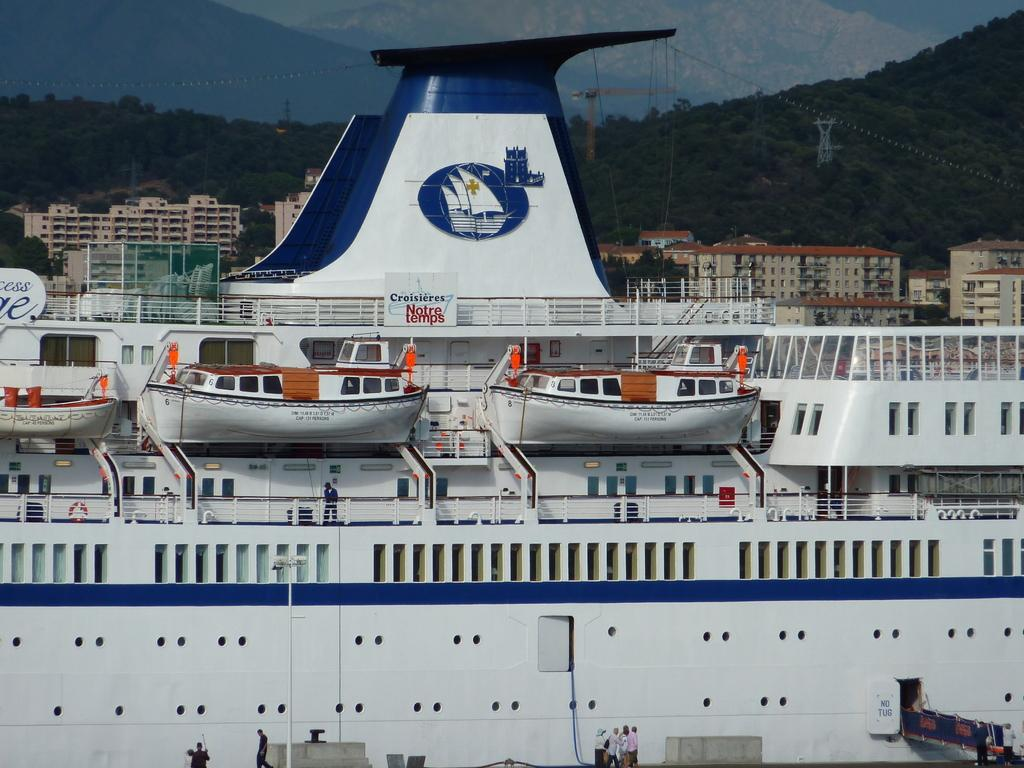What is the main subject of the image? The main subject of the image is a big ship. Are there any smaller vessels near the ship? Yes, there are small boats near the ship. What are people doing on the ship? People are walking on the ship. What can be seen in the background of the image? In the background of the image, there are buildings, trees, a crane, a rope-way, and the sky. What type of suit is the person wearing on the ship? There is no information about the clothing of the people on the ship, so we cannot determine if they are wearing a suit or not. 